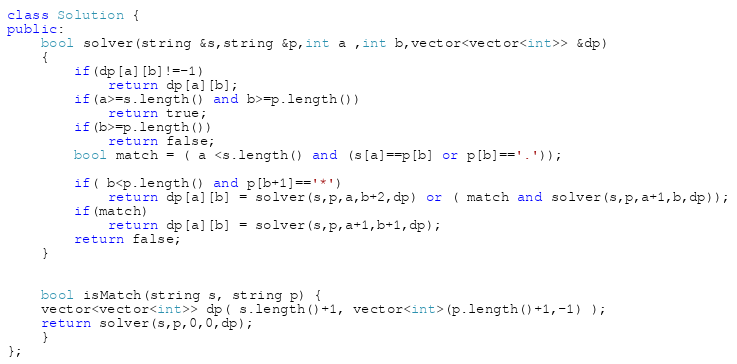<code> <loc_0><loc_0><loc_500><loc_500><_C++_>class Solution {
public:
    bool solver(string &s,string &p,int a ,int b,vector<vector<int>> &dp)
    {   
        if(dp[a][b]!=-1)
            return dp[a][b];
        if(a>=s.length() and b>=p.length()) 
            return true;
        if(b>=p.length())
            return false;
        bool match = ( a <s.length() and (s[a]==p[b] or p[b]=='.'));
        
        if( b<p.length() and p[b+1]=='*')
            return dp[a][b] = solver(s,p,a,b+2,dp) or ( match and solver(s,p,a+1,b,dp));
        if(match)
            return dp[a][b] = solver(s,p,a+1,b+1,dp);
        return false;
    }
    
    
    bool isMatch(string s, string p) {
    vector<vector<int>> dp( s.length()+1, vector<int>(p.length()+1,-1) );
    return solver(s,p,0,0,dp);
    }
};</code> 